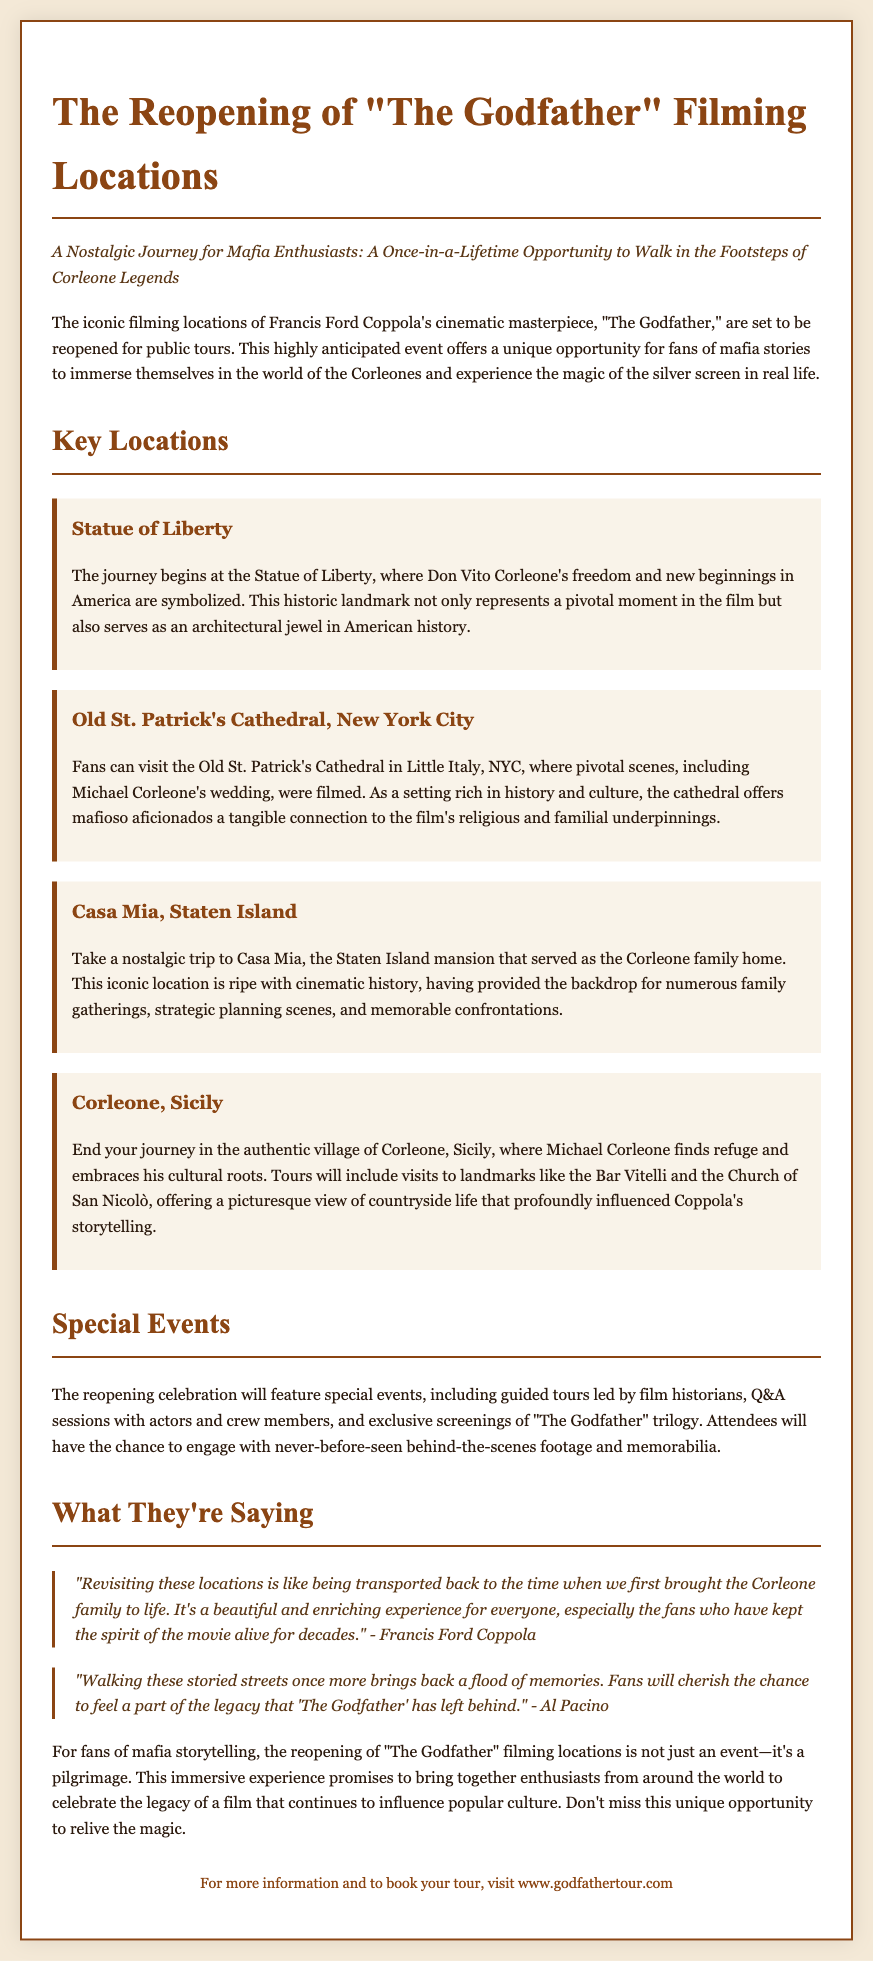What is the title of the press release? The title is the main heading of the document, stating the event being covered.
Answer: The Reopening of "The Godfather" Filming Locations What historic landmark symbolizes Don Vito Corleone's new beginnings? The document mentions this location as the starting point of the journey, emphasizing its significance in the story.
Answer: Statue of Liberty Where was Michael Corleone's wedding filmed? This location is specifically identified as a pivotal scene in the film, providing a significant connection to the story.
Answer: Old St. Patrick's Cathedral, New York City What type of special events will be held during the reopening celebration? The document outlines specific events available to attendees, demonstrating the type of engagement being offered.
Answer: Guided tours Who quoted about being transported back in time during the reopening? This question refers to a notable figure's thoughts expressed in the document, illustrating the personal connection the actors have to the locations.
Answer: Francis Ford Coppola In which Sicilian village does Michael Corleone find refuge? The document indicates this village as part of the journey and highlights its importance to the character's story arc.
Answer: Corleone, Sicily How many locations are mentioned in the document? By counting the key locations listed, we can determine the total number provided.
Answer: Four What is the website for booking tours? The last section of the document provides a resource for fans to obtain more information and book their experiences.
Answer: www.godfathertour.com 